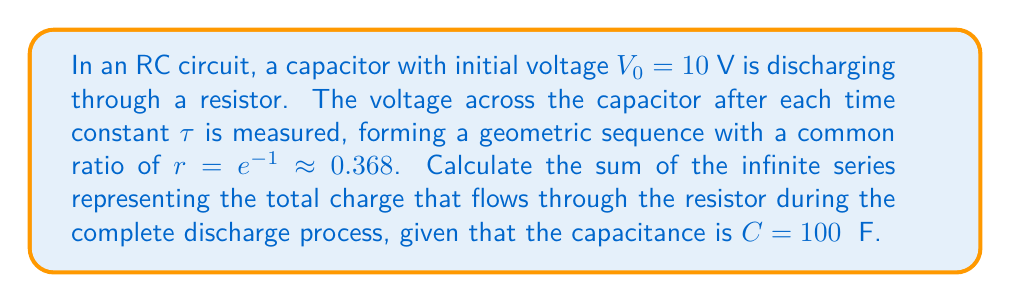What is the answer to this math problem? Let's approach this step-by-step:

1) The voltage across the capacitor after $n$ time constants is given by:
   $$V_n = V_0 r^n = 10 \cdot (e^{-1})^n$$

2) The charge released in each interval is:
   $$\Delta Q_n = C(V_{n-1} - V_n) = C V_0 (r^{n-1} - r^n) = C V_0 r^{n-1}(1-r)$$

3) The total charge released is the sum of all these increments:
   $$Q_{total} = \sum_{n=1}^{\infty} \Delta Q_n = C V_0 (1-r) \sum_{n=1}^{\infty} r^{n-1}$$

4) This is an infinite geometric series with first term $a=1$ and common ratio $r$. The sum of such a series is given by $\frac{a}{1-r}$ when $|r| < 1$.

5) In our case, $r = e^{-1} < 1$, so we can use this formula:
   $$\sum_{n=1}^{\infty} r^{n-1} = \frac{1}{1-r} = \frac{1}{1-e^{-1}}$$

6) Substituting back into our equation for $Q_{total}$:
   $$Q_{total} = C V_0 (1-r) \cdot \frac{1}{1-r} = C V_0$$

7) Now we can plug in our values:
   $$Q_{total} = 100 \times 10^{-6} \cdot 10 = 1000 \times 10^{-6} = 1 \times 10^{-3} \text{ C}$$

Therefore, the total charge that flows through the resistor is 1 mC.
Answer: $1 \times 10^{-3}$ C or 1 mC 